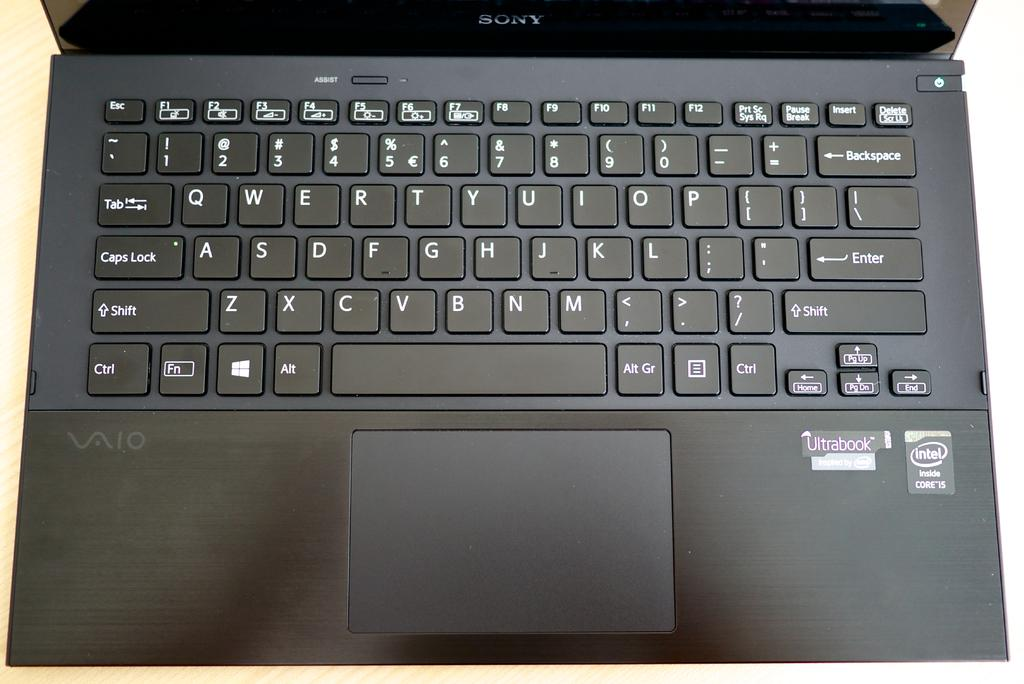<image>
Share a concise interpretation of the image provided. Black Valo laptop that has a sticker saying Intel Inside Core i5. 